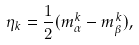Convert formula to latex. <formula><loc_0><loc_0><loc_500><loc_500>\eta _ { k } = { \frac { 1 } { 2 } } ( m _ { \alpha } ^ { k } - m _ { \beta } ^ { k } ) ,</formula> 